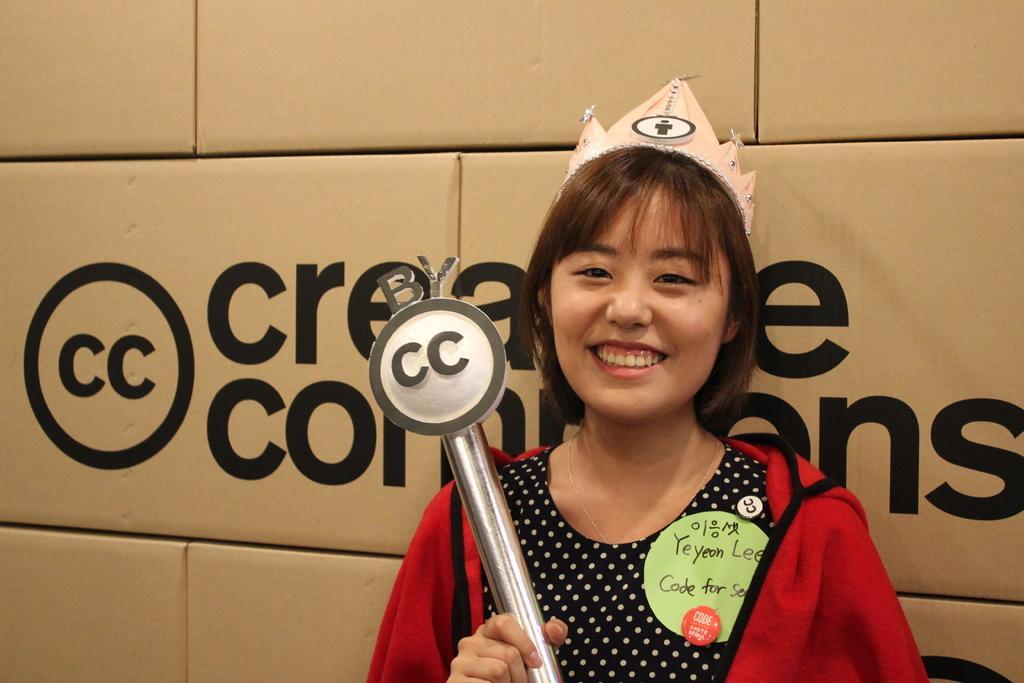In one or two sentences, can you explain what this image depicts? In this picture we can see a woman in the red jacket is holding an object and the woman is smiling. Behind the woman it is written something on the objects. 